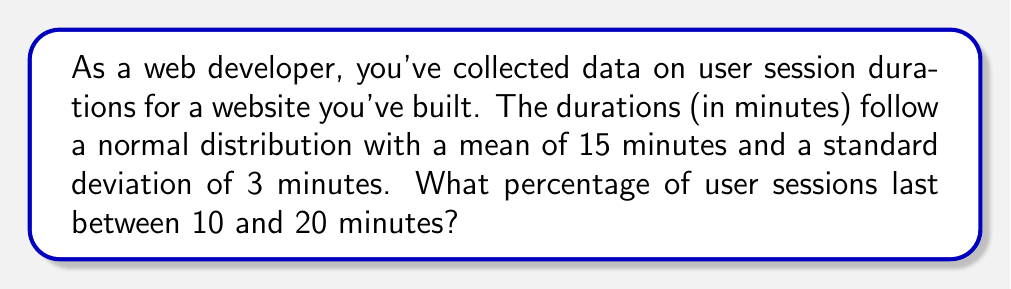What is the answer to this math problem? To solve this problem, we'll use the properties of the normal distribution and the concept of z-scores.

Step 1: Calculate the z-scores for the given range.
For 10 minutes: $z_1 = \frac{10 - 15}{3} = -1.67$
For 20 minutes: $z_2 = \frac{20 - 15}{3} = 1.67$

Step 2: Use the standard normal distribution table or a calculator to find the area under the curve between these z-scores.

The area between -1.67 and 1.67 in a standard normal distribution is approximately 0.9050 or 90.50%.

Step 3: Convert the result to a percentage.
0.9050 * 100 = 90.50%

Therefore, approximately 90.50% of user sessions last between 10 and 20 minutes.
Answer: 90.50% 